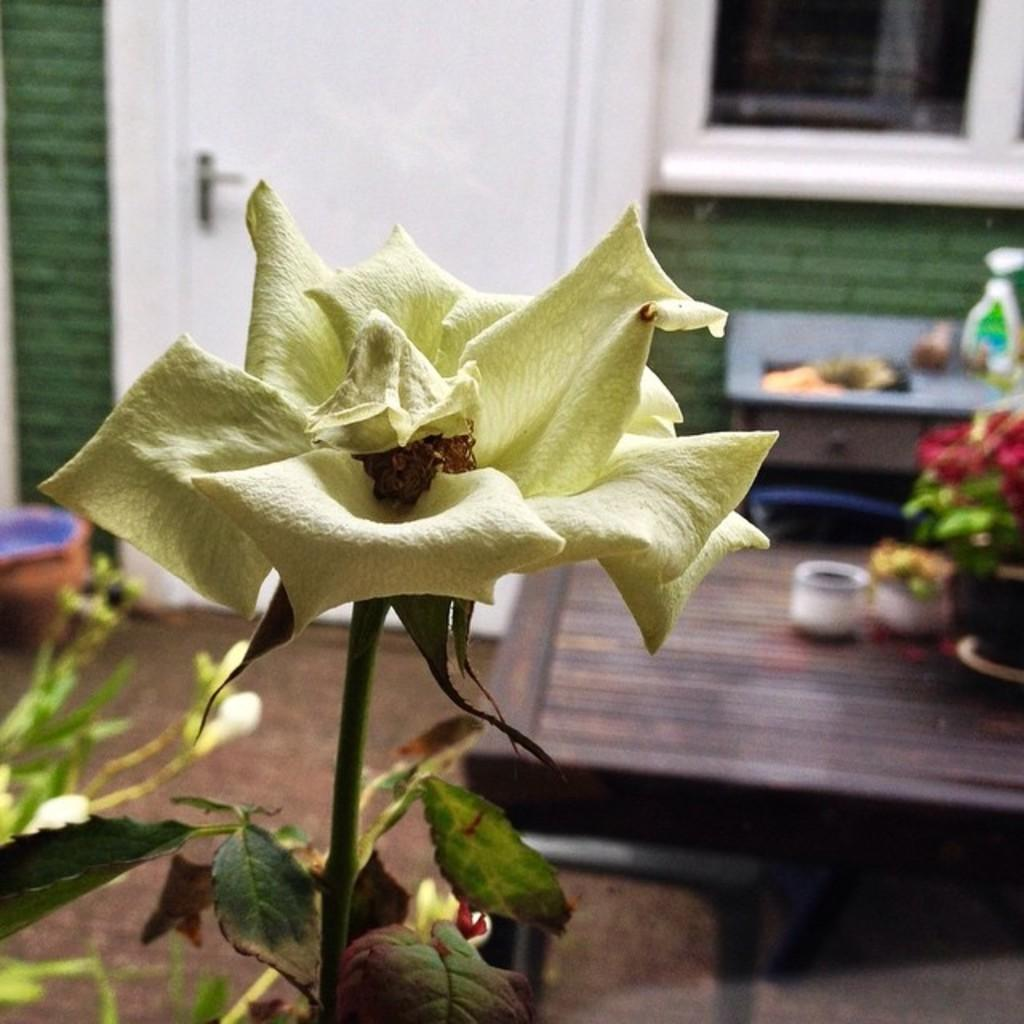What piece of furniture is present in the image? There is a table in the image. What is placed on the table? There is a plant on the table. What is special about the plant? The plant has a flower. What architectural feature can be seen in the image? There is a door in the image. What type of background is visible in the image? There is a wall visible in the image. What flavor of pail can be seen in the image? There is no pail present in the image, and therefore no flavor can be associated with it. What type of party is taking place in the image? There is no party depicted in the image. 